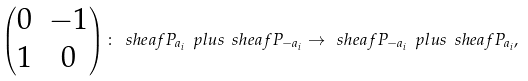Convert formula to latex. <formula><loc_0><loc_0><loc_500><loc_500>\begin{pmatrix} 0 & - 1 \\ 1 & 0 \end{pmatrix} \colon \ s h e a f { P } _ { a _ { i } } \ p l u s \ s h e a f { P } _ { - a _ { i } } \to \ s h e a f { P } _ { - a _ { i } } \ p l u s \ s h e a f { P } _ { a _ { i } } ,</formula> 